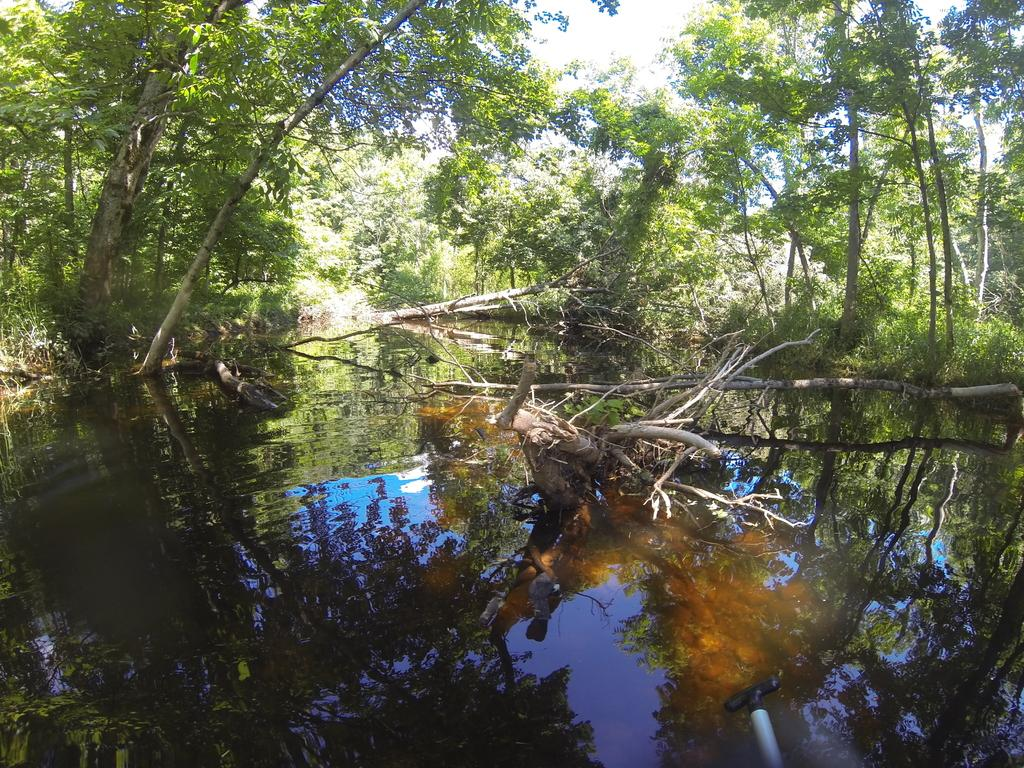What is the primary element visible in the image? There is water in the image. What type of natural vegetation can be seen in the image? There are trees in the image. Can you describe the object in the image? Unfortunately, the facts provided do not give enough information to describe the object in the image. What is visible in the background of the image? The sky is visible in the background of the image. What type of juice is being served at the beginning of the image? There is no juice or any indication of a beginning or end in the image; it only features water, trees, and an unspecified object. 